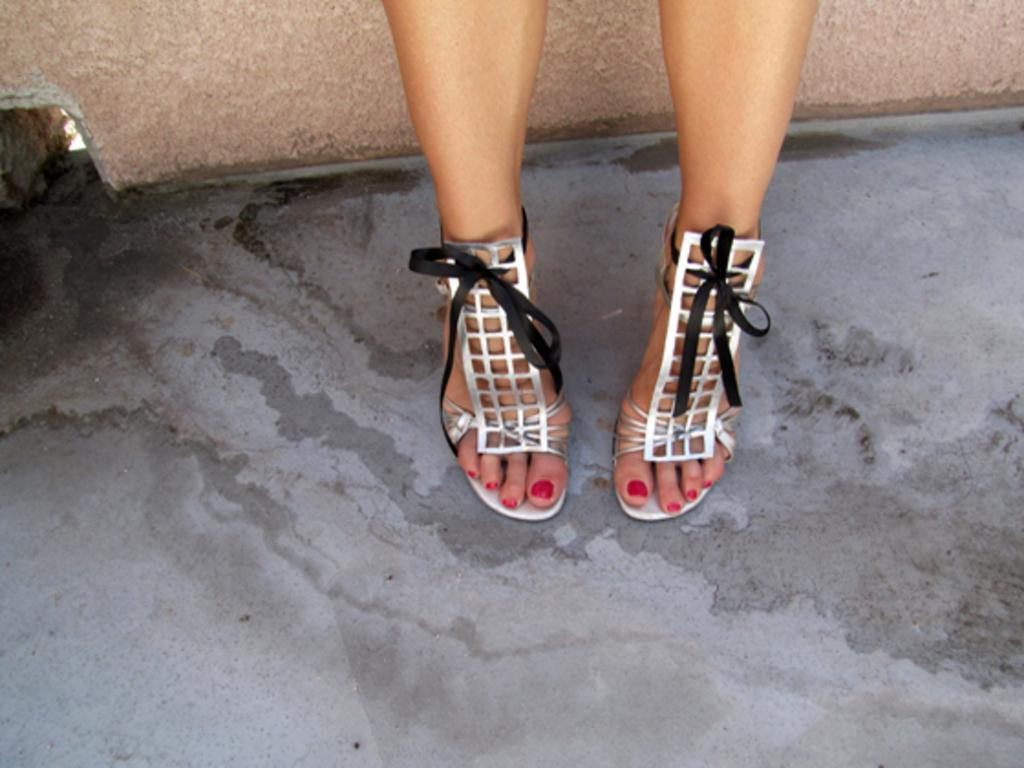What part of a person can be seen in the image? There are legs of a person visible in the image. What type of footwear is the person wearing? The person is wearing footwear. On what surface are the legs placed? The legs are on a surface. What is visible at the top of the image? There is a wall at the top of the image. How does the person use the whip in the image? There is no whip present in the image. What type of polish is applied to the legs in the image? There is no polish applied to the legs in the image. 